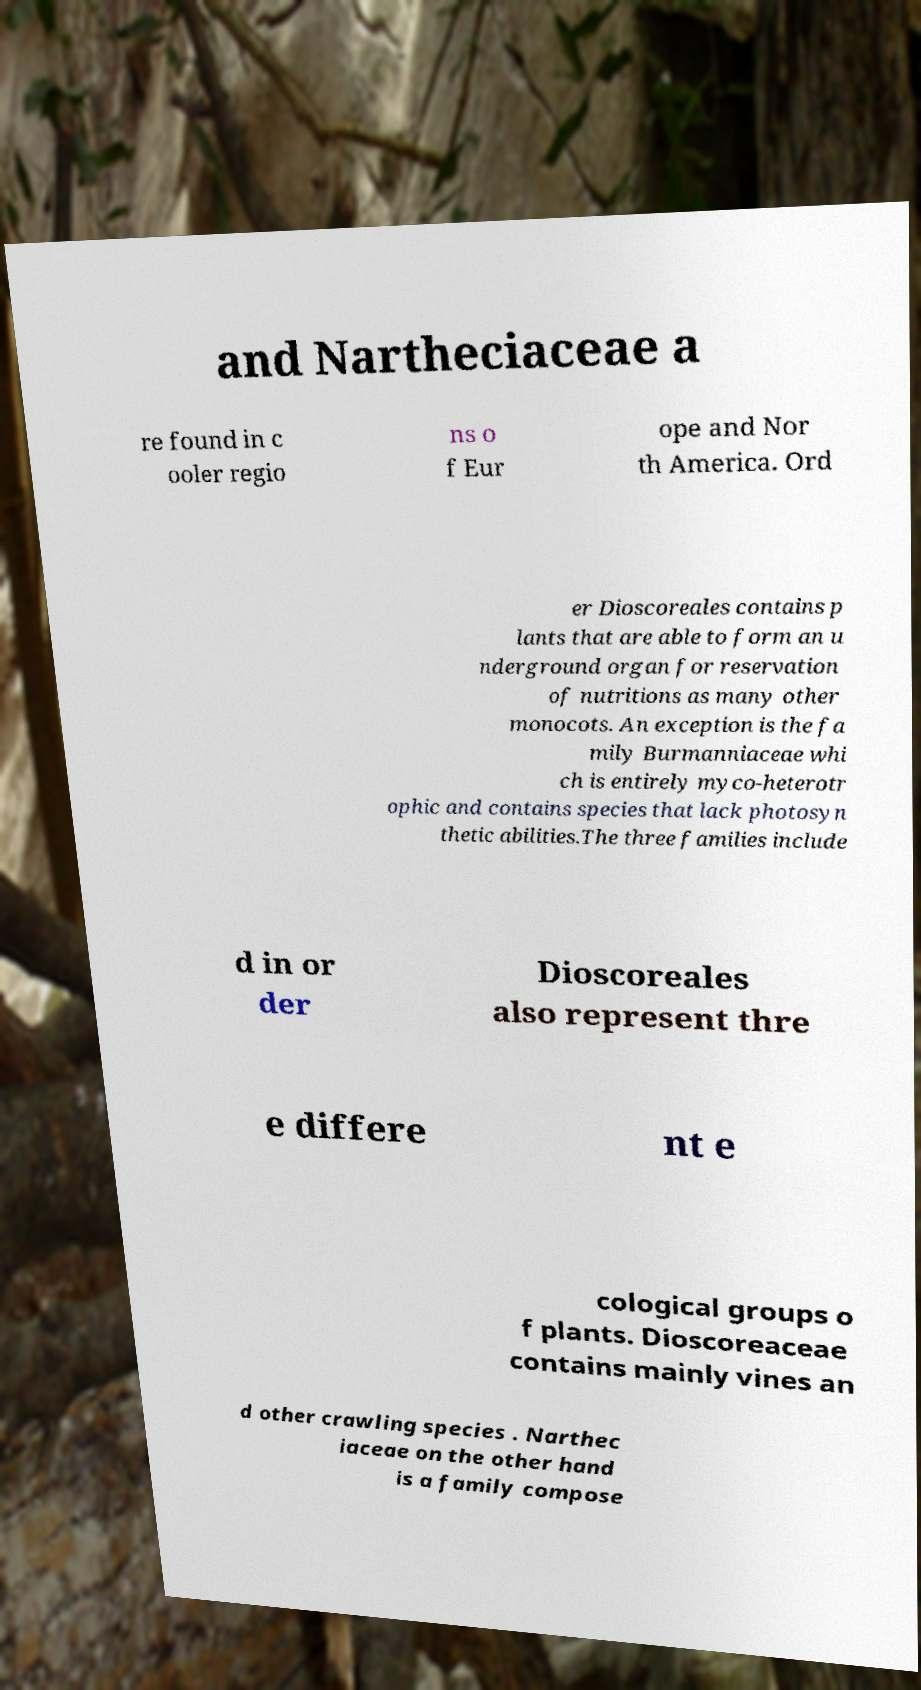Could you extract and type out the text from this image? and Nartheciaceae a re found in c ooler regio ns o f Eur ope and Nor th America. Ord er Dioscoreales contains p lants that are able to form an u nderground organ for reservation of nutritions as many other monocots. An exception is the fa mily Burmanniaceae whi ch is entirely myco-heterotr ophic and contains species that lack photosyn thetic abilities.The three families include d in or der Dioscoreales also represent thre e differe nt e cological groups o f plants. Dioscoreaceae contains mainly vines an d other crawling species . Narthec iaceae on the other hand is a family compose 